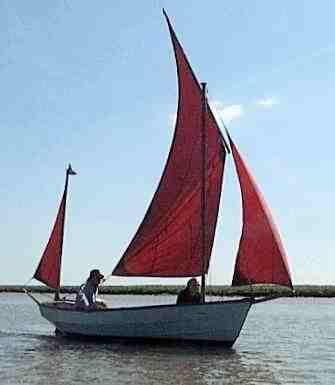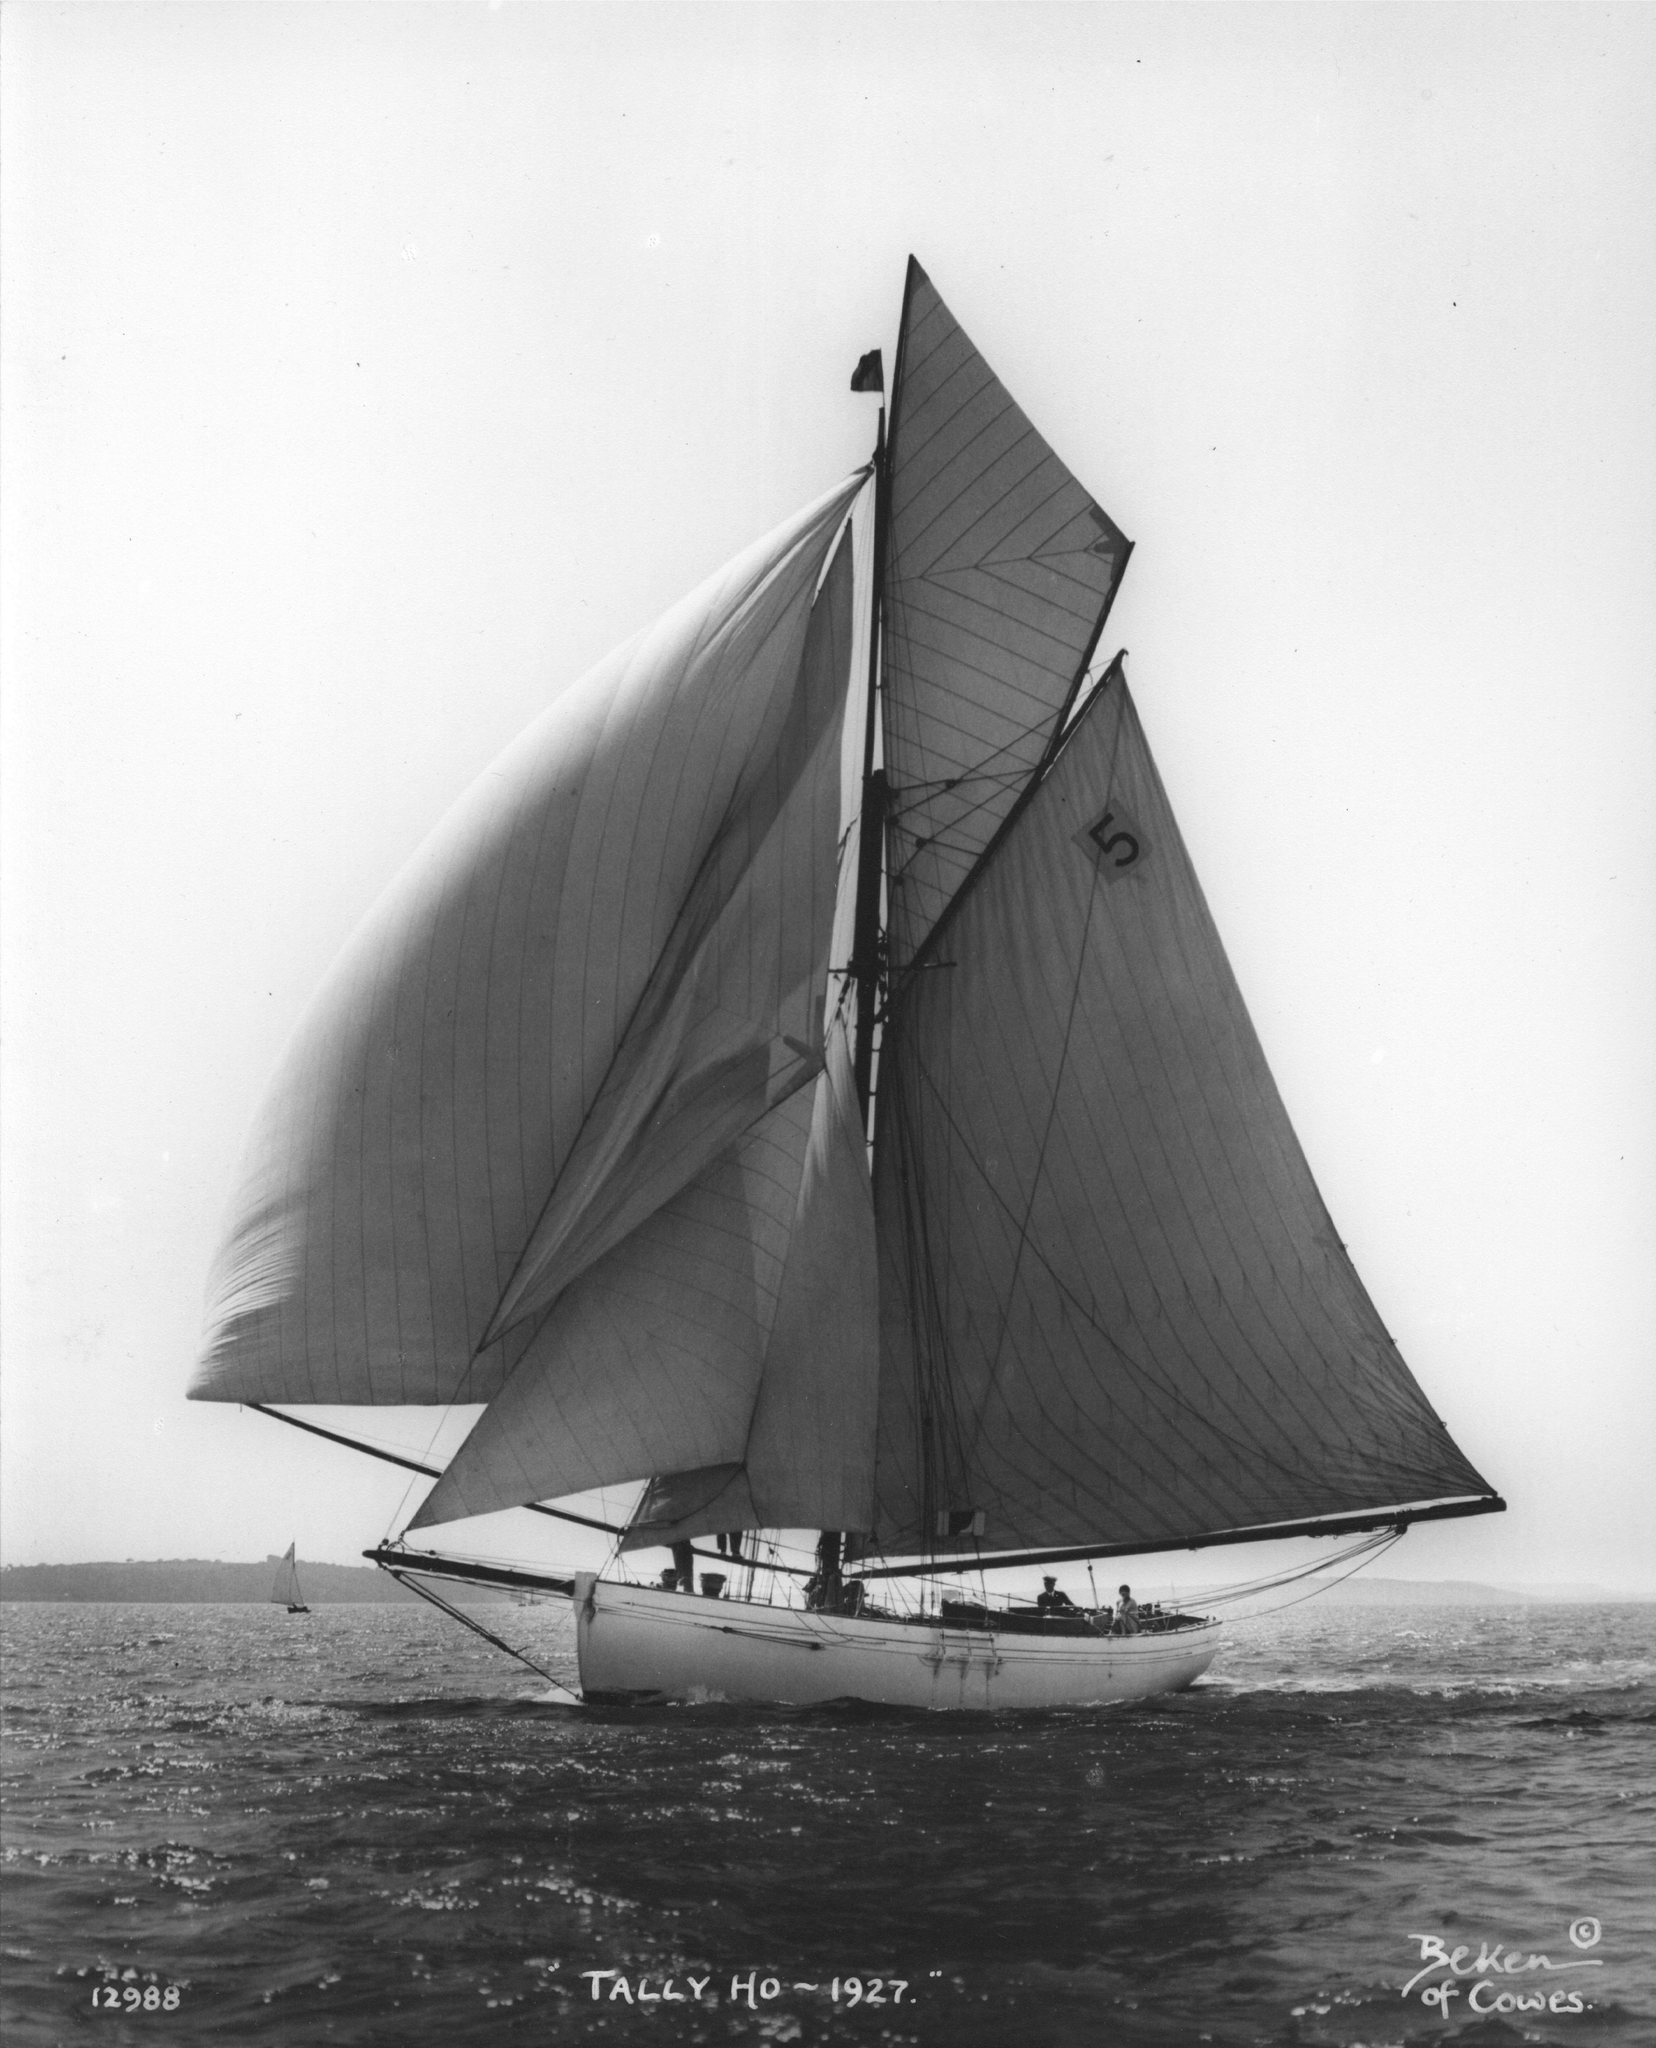The first image is the image on the left, the second image is the image on the right. Assess this claim about the two images: "In one of the images there is a green and brown boat with brown sails". Correct or not? Answer yes or no. No. 